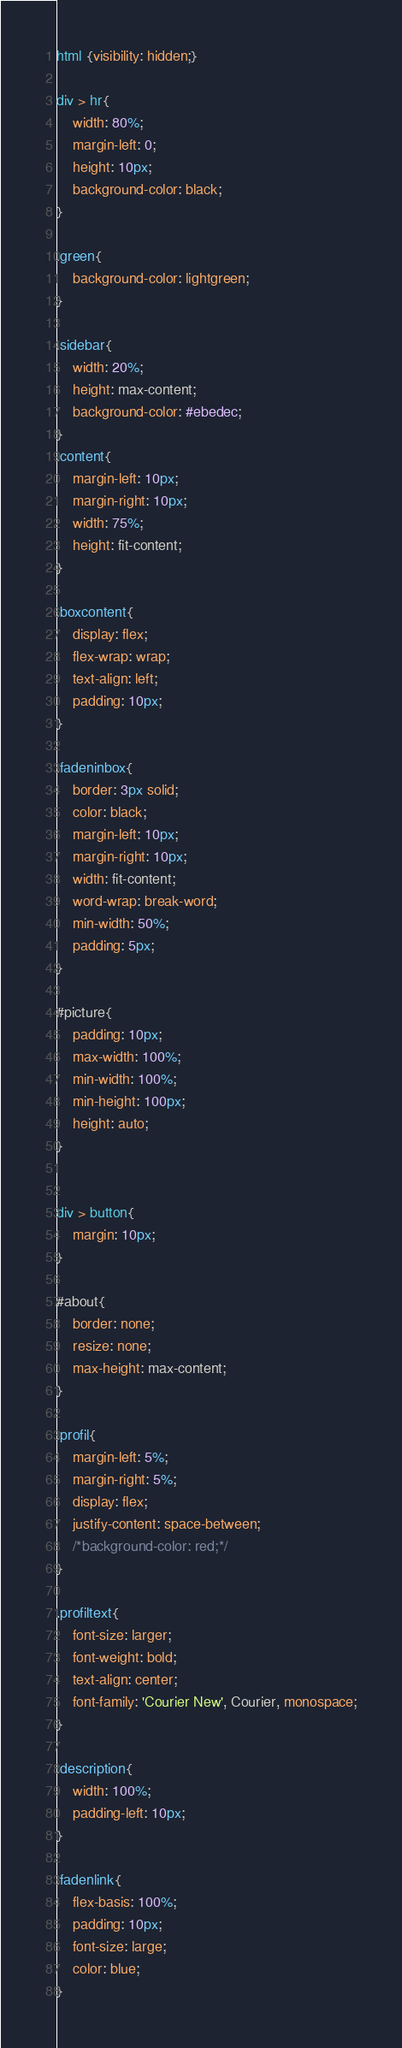Convert code to text. <code><loc_0><loc_0><loc_500><loc_500><_CSS_>html {visibility: hidden;}

div > hr{
    width: 80%;
    margin-left: 0;
    height: 10px;
    background-color: black;
}

.green{
    background-color: lightgreen;
}

.sidebar{
    width: 20%;
    height: max-content;
    background-color: #ebedec;
}
.content{
    margin-left: 10px;
    margin-right: 10px;
    width: 75%;
    height: fit-content;
}

.boxcontent{
    display: flex;
    flex-wrap: wrap;
    text-align: left;
    padding: 10px;
}

.fadeninbox{
    border: 3px solid;
    color: black;
    margin-left: 10px;
    margin-right: 10px;
    width: fit-content;
    word-wrap: break-word;
    min-width: 50%;
    padding: 5px;
}

#picture{
    padding: 10px;
    max-width: 100%;
    min-width: 100%;
    min-height: 100px;
    height: auto;
}


div > button{
    margin: 10px;
}

#about{
    border: none;
    resize: none;
    max-height: max-content;
}

.profil{
    margin-left: 5%;
    margin-right: 5%;
    display: flex;
    justify-content: space-between;
    /*background-color: red;*/
}

.profiltext{
    font-size: larger;
    font-weight: bold;
    text-align: center;
    font-family: 'Courier New', Courier, monospace;
}

.description{
    width: 100%;
    padding-left: 10px;
}

.fadenlink{
    flex-basis: 100%;
    padding: 10px;
    font-size: large;
    color: blue;
}</code> 